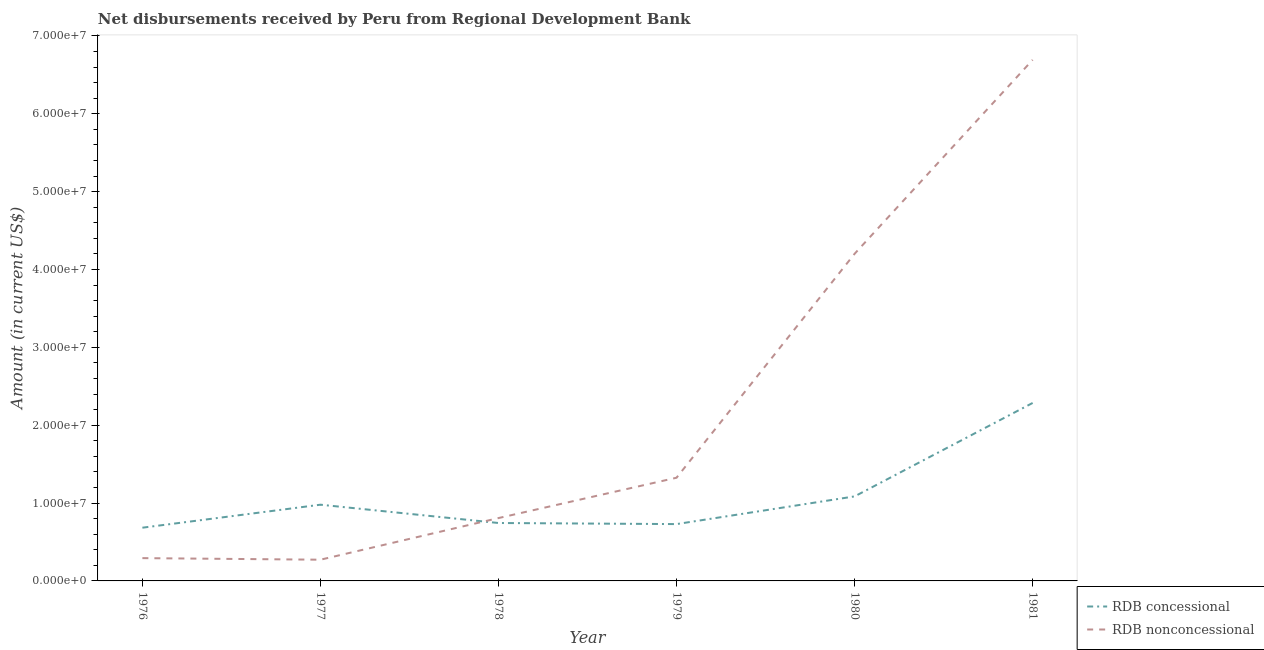How many different coloured lines are there?
Ensure brevity in your answer.  2. Does the line corresponding to net non concessional disbursements from rdb intersect with the line corresponding to net concessional disbursements from rdb?
Your answer should be compact. Yes. Is the number of lines equal to the number of legend labels?
Make the answer very short. Yes. What is the net non concessional disbursements from rdb in 1979?
Your answer should be very brief. 1.33e+07. Across all years, what is the maximum net concessional disbursements from rdb?
Provide a succinct answer. 2.29e+07. Across all years, what is the minimum net non concessional disbursements from rdb?
Give a very brief answer. 2.72e+06. In which year was the net non concessional disbursements from rdb maximum?
Ensure brevity in your answer.  1981. In which year was the net concessional disbursements from rdb minimum?
Provide a short and direct response. 1976. What is the total net non concessional disbursements from rdb in the graph?
Offer a terse response. 1.36e+08. What is the difference between the net concessional disbursements from rdb in 1976 and that in 1981?
Make the answer very short. -1.60e+07. What is the difference between the net concessional disbursements from rdb in 1978 and the net non concessional disbursements from rdb in 1977?
Your answer should be very brief. 4.71e+06. What is the average net non concessional disbursements from rdb per year?
Provide a short and direct response. 2.27e+07. In the year 1979, what is the difference between the net concessional disbursements from rdb and net non concessional disbursements from rdb?
Offer a terse response. -5.95e+06. In how many years, is the net concessional disbursements from rdb greater than 26000000 US$?
Ensure brevity in your answer.  0. What is the ratio of the net non concessional disbursements from rdb in 1977 to that in 1980?
Provide a short and direct response. 0.06. Is the net concessional disbursements from rdb in 1979 less than that in 1981?
Provide a short and direct response. Yes. Is the difference between the net non concessional disbursements from rdb in 1976 and 1977 greater than the difference between the net concessional disbursements from rdb in 1976 and 1977?
Give a very brief answer. Yes. What is the difference between the highest and the second highest net non concessional disbursements from rdb?
Keep it short and to the point. 2.49e+07. What is the difference between the highest and the lowest net concessional disbursements from rdb?
Ensure brevity in your answer.  1.60e+07. In how many years, is the net concessional disbursements from rdb greater than the average net concessional disbursements from rdb taken over all years?
Offer a very short reply. 2. Does the net concessional disbursements from rdb monotonically increase over the years?
Make the answer very short. No. How many lines are there?
Your answer should be compact. 2. How many years are there in the graph?
Give a very brief answer. 6. Are the values on the major ticks of Y-axis written in scientific E-notation?
Offer a terse response. Yes. Does the graph contain grids?
Provide a succinct answer. No. How are the legend labels stacked?
Your answer should be compact. Vertical. What is the title of the graph?
Make the answer very short. Net disbursements received by Peru from Regional Development Bank. Does "Domestic Liabilities" appear as one of the legend labels in the graph?
Offer a very short reply. No. What is the label or title of the X-axis?
Your answer should be very brief. Year. What is the Amount (in current US$) in RDB concessional in 1976?
Provide a succinct answer. 6.84e+06. What is the Amount (in current US$) of RDB nonconcessional in 1976?
Offer a terse response. 2.93e+06. What is the Amount (in current US$) in RDB concessional in 1977?
Keep it short and to the point. 9.79e+06. What is the Amount (in current US$) of RDB nonconcessional in 1977?
Your answer should be compact. 2.72e+06. What is the Amount (in current US$) of RDB concessional in 1978?
Provide a succinct answer. 7.44e+06. What is the Amount (in current US$) of RDB nonconcessional in 1978?
Provide a short and direct response. 8.07e+06. What is the Amount (in current US$) in RDB concessional in 1979?
Your answer should be compact. 7.30e+06. What is the Amount (in current US$) in RDB nonconcessional in 1979?
Offer a very short reply. 1.33e+07. What is the Amount (in current US$) of RDB concessional in 1980?
Offer a very short reply. 1.09e+07. What is the Amount (in current US$) of RDB nonconcessional in 1980?
Provide a short and direct response. 4.20e+07. What is the Amount (in current US$) of RDB concessional in 1981?
Provide a succinct answer. 2.29e+07. What is the Amount (in current US$) in RDB nonconcessional in 1981?
Provide a short and direct response. 6.69e+07. Across all years, what is the maximum Amount (in current US$) of RDB concessional?
Your answer should be compact. 2.29e+07. Across all years, what is the maximum Amount (in current US$) of RDB nonconcessional?
Your response must be concise. 6.69e+07. Across all years, what is the minimum Amount (in current US$) in RDB concessional?
Your response must be concise. 6.84e+06. Across all years, what is the minimum Amount (in current US$) in RDB nonconcessional?
Ensure brevity in your answer.  2.72e+06. What is the total Amount (in current US$) in RDB concessional in the graph?
Your answer should be compact. 6.51e+07. What is the total Amount (in current US$) in RDB nonconcessional in the graph?
Your answer should be very brief. 1.36e+08. What is the difference between the Amount (in current US$) in RDB concessional in 1976 and that in 1977?
Your answer should be compact. -2.95e+06. What is the difference between the Amount (in current US$) of RDB nonconcessional in 1976 and that in 1977?
Your answer should be very brief. 2.03e+05. What is the difference between the Amount (in current US$) in RDB concessional in 1976 and that in 1978?
Your answer should be compact. -6.04e+05. What is the difference between the Amount (in current US$) in RDB nonconcessional in 1976 and that in 1978?
Ensure brevity in your answer.  -5.14e+06. What is the difference between the Amount (in current US$) in RDB concessional in 1976 and that in 1979?
Give a very brief answer. -4.64e+05. What is the difference between the Amount (in current US$) of RDB nonconcessional in 1976 and that in 1979?
Your response must be concise. -1.03e+07. What is the difference between the Amount (in current US$) of RDB concessional in 1976 and that in 1980?
Give a very brief answer. -4.02e+06. What is the difference between the Amount (in current US$) in RDB nonconcessional in 1976 and that in 1980?
Keep it short and to the point. -3.91e+07. What is the difference between the Amount (in current US$) in RDB concessional in 1976 and that in 1981?
Your response must be concise. -1.60e+07. What is the difference between the Amount (in current US$) in RDB nonconcessional in 1976 and that in 1981?
Make the answer very short. -6.40e+07. What is the difference between the Amount (in current US$) in RDB concessional in 1977 and that in 1978?
Make the answer very short. 2.35e+06. What is the difference between the Amount (in current US$) of RDB nonconcessional in 1977 and that in 1978?
Ensure brevity in your answer.  -5.35e+06. What is the difference between the Amount (in current US$) in RDB concessional in 1977 and that in 1979?
Your response must be concise. 2.49e+06. What is the difference between the Amount (in current US$) in RDB nonconcessional in 1977 and that in 1979?
Give a very brief answer. -1.05e+07. What is the difference between the Amount (in current US$) in RDB concessional in 1977 and that in 1980?
Make the answer very short. -1.07e+06. What is the difference between the Amount (in current US$) in RDB nonconcessional in 1977 and that in 1980?
Your answer should be very brief. -3.93e+07. What is the difference between the Amount (in current US$) of RDB concessional in 1977 and that in 1981?
Give a very brief answer. -1.31e+07. What is the difference between the Amount (in current US$) in RDB nonconcessional in 1977 and that in 1981?
Provide a short and direct response. -6.42e+07. What is the difference between the Amount (in current US$) of RDB concessional in 1978 and that in 1979?
Keep it short and to the point. 1.40e+05. What is the difference between the Amount (in current US$) of RDB nonconcessional in 1978 and that in 1979?
Ensure brevity in your answer.  -5.18e+06. What is the difference between the Amount (in current US$) in RDB concessional in 1978 and that in 1980?
Make the answer very short. -3.42e+06. What is the difference between the Amount (in current US$) in RDB nonconcessional in 1978 and that in 1980?
Keep it short and to the point. -3.39e+07. What is the difference between the Amount (in current US$) of RDB concessional in 1978 and that in 1981?
Keep it short and to the point. -1.54e+07. What is the difference between the Amount (in current US$) of RDB nonconcessional in 1978 and that in 1981?
Keep it short and to the point. -5.88e+07. What is the difference between the Amount (in current US$) of RDB concessional in 1979 and that in 1980?
Offer a very short reply. -3.56e+06. What is the difference between the Amount (in current US$) of RDB nonconcessional in 1979 and that in 1980?
Offer a terse response. -2.88e+07. What is the difference between the Amount (in current US$) of RDB concessional in 1979 and that in 1981?
Offer a terse response. -1.56e+07. What is the difference between the Amount (in current US$) of RDB nonconcessional in 1979 and that in 1981?
Provide a succinct answer. -5.37e+07. What is the difference between the Amount (in current US$) in RDB concessional in 1980 and that in 1981?
Your answer should be very brief. -1.20e+07. What is the difference between the Amount (in current US$) of RDB nonconcessional in 1980 and that in 1981?
Offer a terse response. -2.49e+07. What is the difference between the Amount (in current US$) of RDB concessional in 1976 and the Amount (in current US$) of RDB nonconcessional in 1977?
Your answer should be very brief. 4.11e+06. What is the difference between the Amount (in current US$) in RDB concessional in 1976 and the Amount (in current US$) in RDB nonconcessional in 1978?
Your response must be concise. -1.24e+06. What is the difference between the Amount (in current US$) in RDB concessional in 1976 and the Amount (in current US$) in RDB nonconcessional in 1979?
Your answer should be compact. -6.42e+06. What is the difference between the Amount (in current US$) in RDB concessional in 1976 and the Amount (in current US$) in RDB nonconcessional in 1980?
Your response must be concise. -3.52e+07. What is the difference between the Amount (in current US$) in RDB concessional in 1976 and the Amount (in current US$) in RDB nonconcessional in 1981?
Provide a short and direct response. -6.01e+07. What is the difference between the Amount (in current US$) in RDB concessional in 1977 and the Amount (in current US$) in RDB nonconcessional in 1978?
Your answer should be very brief. 1.72e+06. What is the difference between the Amount (in current US$) of RDB concessional in 1977 and the Amount (in current US$) of RDB nonconcessional in 1979?
Make the answer very short. -3.46e+06. What is the difference between the Amount (in current US$) of RDB concessional in 1977 and the Amount (in current US$) of RDB nonconcessional in 1980?
Your answer should be very brief. -3.22e+07. What is the difference between the Amount (in current US$) in RDB concessional in 1977 and the Amount (in current US$) in RDB nonconcessional in 1981?
Your answer should be compact. -5.71e+07. What is the difference between the Amount (in current US$) of RDB concessional in 1978 and the Amount (in current US$) of RDB nonconcessional in 1979?
Your answer should be very brief. -5.81e+06. What is the difference between the Amount (in current US$) of RDB concessional in 1978 and the Amount (in current US$) of RDB nonconcessional in 1980?
Make the answer very short. -3.46e+07. What is the difference between the Amount (in current US$) of RDB concessional in 1978 and the Amount (in current US$) of RDB nonconcessional in 1981?
Offer a terse response. -5.95e+07. What is the difference between the Amount (in current US$) in RDB concessional in 1979 and the Amount (in current US$) in RDB nonconcessional in 1980?
Your response must be concise. -3.47e+07. What is the difference between the Amount (in current US$) of RDB concessional in 1979 and the Amount (in current US$) of RDB nonconcessional in 1981?
Keep it short and to the point. -5.96e+07. What is the difference between the Amount (in current US$) in RDB concessional in 1980 and the Amount (in current US$) in RDB nonconcessional in 1981?
Make the answer very short. -5.61e+07. What is the average Amount (in current US$) in RDB concessional per year?
Your answer should be very brief. 1.08e+07. What is the average Amount (in current US$) in RDB nonconcessional per year?
Your answer should be very brief. 2.27e+07. In the year 1976, what is the difference between the Amount (in current US$) in RDB concessional and Amount (in current US$) in RDB nonconcessional?
Offer a terse response. 3.91e+06. In the year 1977, what is the difference between the Amount (in current US$) of RDB concessional and Amount (in current US$) of RDB nonconcessional?
Your answer should be compact. 7.06e+06. In the year 1978, what is the difference between the Amount (in current US$) of RDB concessional and Amount (in current US$) of RDB nonconcessional?
Provide a short and direct response. -6.34e+05. In the year 1979, what is the difference between the Amount (in current US$) of RDB concessional and Amount (in current US$) of RDB nonconcessional?
Your response must be concise. -5.95e+06. In the year 1980, what is the difference between the Amount (in current US$) in RDB concessional and Amount (in current US$) in RDB nonconcessional?
Keep it short and to the point. -3.12e+07. In the year 1981, what is the difference between the Amount (in current US$) in RDB concessional and Amount (in current US$) in RDB nonconcessional?
Keep it short and to the point. -4.41e+07. What is the ratio of the Amount (in current US$) of RDB concessional in 1976 to that in 1977?
Your response must be concise. 0.7. What is the ratio of the Amount (in current US$) in RDB nonconcessional in 1976 to that in 1977?
Your response must be concise. 1.07. What is the ratio of the Amount (in current US$) in RDB concessional in 1976 to that in 1978?
Your answer should be compact. 0.92. What is the ratio of the Amount (in current US$) in RDB nonconcessional in 1976 to that in 1978?
Give a very brief answer. 0.36. What is the ratio of the Amount (in current US$) in RDB concessional in 1976 to that in 1979?
Your answer should be very brief. 0.94. What is the ratio of the Amount (in current US$) of RDB nonconcessional in 1976 to that in 1979?
Offer a very short reply. 0.22. What is the ratio of the Amount (in current US$) of RDB concessional in 1976 to that in 1980?
Offer a terse response. 0.63. What is the ratio of the Amount (in current US$) in RDB nonconcessional in 1976 to that in 1980?
Keep it short and to the point. 0.07. What is the ratio of the Amount (in current US$) of RDB concessional in 1976 to that in 1981?
Your response must be concise. 0.3. What is the ratio of the Amount (in current US$) of RDB nonconcessional in 1976 to that in 1981?
Offer a terse response. 0.04. What is the ratio of the Amount (in current US$) of RDB concessional in 1977 to that in 1978?
Your response must be concise. 1.32. What is the ratio of the Amount (in current US$) of RDB nonconcessional in 1977 to that in 1978?
Offer a very short reply. 0.34. What is the ratio of the Amount (in current US$) of RDB concessional in 1977 to that in 1979?
Your response must be concise. 1.34. What is the ratio of the Amount (in current US$) in RDB nonconcessional in 1977 to that in 1979?
Keep it short and to the point. 0.21. What is the ratio of the Amount (in current US$) in RDB concessional in 1977 to that in 1980?
Provide a succinct answer. 0.9. What is the ratio of the Amount (in current US$) of RDB nonconcessional in 1977 to that in 1980?
Provide a short and direct response. 0.06. What is the ratio of the Amount (in current US$) of RDB concessional in 1977 to that in 1981?
Provide a short and direct response. 0.43. What is the ratio of the Amount (in current US$) of RDB nonconcessional in 1977 to that in 1981?
Provide a succinct answer. 0.04. What is the ratio of the Amount (in current US$) in RDB concessional in 1978 to that in 1979?
Your answer should be very brief. 1.02. What is the ratio of the Amount (in current US$) in RDB nonconcessional in 1978 to that in 1979?
Provide a short and direct response. 0.61. What is the ratio of the Amount (in current US$) of RDB concessional in 1978 to that in 1980?
Your answer should be very brief. 0.69. What is the ratio of the Amount (in current US$) of RDB nonconcessional in 1978 to that in 1980?
Give a very brief answer. 0.19. What is the ratio of the Amount (in current US$) in RDB concessional in 1978 to that in 1981?
Offer a terse response. 0.33. What is the ratio of the Amount (in current US$) of RDB nonconcessional in 1978 to that in 1981?
Your answer should be compact. 0.12. What is the ratio of the Amount (in current US$) of RDB concessional in 1979 to that in 1980?
Make the answer very short. 0.67. What is the ratio of the Amount (in current US$) in RDB nonconcessional in 1979 to that in 1980?
Make the answer very short. 0.32. What is the ratio of the Amount (in current US$) of RDB concessional in 1979 to that in 1981?
Your answer should be compact. 0.32. What is the ratio of the Amount (in current US$) in RDB nonconcessional in 1979 to that in 1981?
Offer a very short reply. 0.2. What is the ratio of the Amount (in current US$) in RDB concessional in 1980 to that in 1981?
Offer a terse response. 0.47. What is the ratio of the Amount (in current US$) in RDB nonconcessional in 1980 to that in 1981?
Your response must be concise. 0.63. What is the difference between the highest and the second highest Amount (in current US$) in RDB concessional?
Make the answer very short. 1.20e+07. What is the difference between the highest and the second highest Amount (in current US$) of RDB nonconcessional?
Make the answer very short. 2.49e+07. What is the difference between the highest and the lowest Amount (in current US$) of RDB concessional?
Provide a succinct answer. 1.60e+07. What is the difference between the highest and the lowest Amount (in current US$) in RDB nonconcessional?
Your response must be concise. 6.42e+07. 